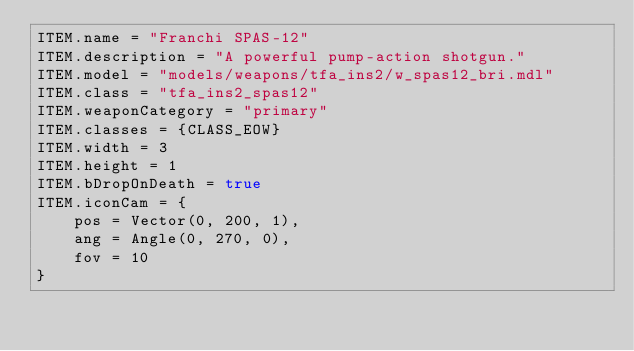Convert code to text. <code><loc_0><loc_0><loc_500><loc_500><_Lua_>ITEM.name = "Franchi SPAS-12"
ITEM.description = "A powerful pump-action shotgun."
ITEM.model = "models/weapons/tfa_ins2/w_spas12_bri.mdl"
ITEM.class = "tfa_ins2_spas12"
ITEM.weaponCategory = "primary"
ITEM.classes = {CLASS_EOW}
ITEM.width = 3
ITEM.height = 1
ITEM.bDropOnDeath = true
ITEM.iconCam = {
    pos = Vector(0, 200, 1),
    ang = Angle(0, 270, 0),
    fov = 10
}</code> 